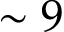<formula> <loc_0><loc_0><loc_500><loc_500>\sim 9</formula> 